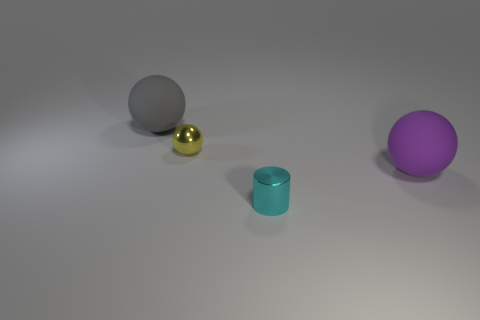What is the material of the large gray object?
Offer a very short reply. Rubber. Is there anything else that is the same color as the tiny shiny ball?
Give a very brief answer. No. Do the large gray object and the cyan metallic object have the same shape?
Keep it short and to the point. No. How big is the rubber sphere behind the large matte object in front of the metal thing behind the purple thing?
Keep it short and to the point. Large. How many other things are there of the same material as the small cyan thing?
Give a very brief answer. 1. What color is the small object that is behind the tiny cyan metal object?
Provide a succinct answer. Yellow. What is the material of the large sphere that is on the left side of the large ball to the right of the matte ball that is left of the tiny yellow ball?
Your answer should be very brief. Rubber. Is there a large cyan object of the same shape as the big purple thing?
Offer a terse response. No. There is another metallic object that is the same size as the cyan metallic thing; what is its shape?
Provide a short and direct response. Sphere. What number of balls are in front of the gray matte ball and left of the shiny cylinder?
Provide a short and direct response. 1. 